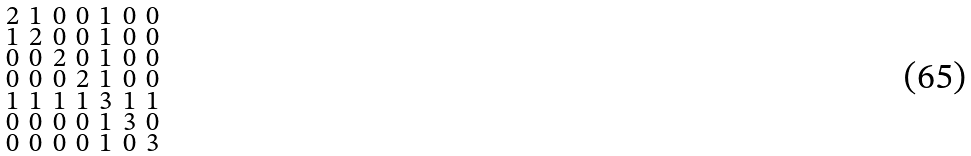<formula> <loc_0><loc_0><loc_500><loc_500>\begin{smallmatrix} 2 & 1 & 0 & 0 & 1 & 0 & 0 \\ 1 & 2 & 0 & 0 & 1 & 0 & 0 \\ 0 & 0 & 2 & 0 & 1 & 0 & 0 \\ 0 & 0 & 0 & 2 & 1 & 0 & 0 \\ 1 & 1 & 1 & 1 & 3 & 1 & 1 \\ 0 & 0 & 0 & 0 & 1 & 3 & 0 \\ 0 & 0 & 0 & 0 & 1 & 0 & 3 \end{smallmatrix}</formula> 